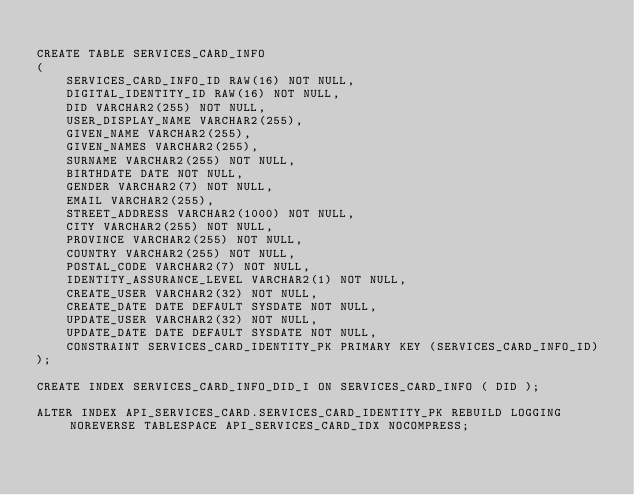Convert code to text. <code><loc_0><loc_0><loc_500><loc_500><_SQL_>
CREATE TABLE SERVICES_CARD_INFO
(
    SERVICES_CARD_INFO_ID RAW(16) NOT NULL,
    DIGITAL_IDENTITY_ID RAW(16) NOT NULL,
    DID VARCHAR2(255) NOT NULL,
    USER_DISPLAY_NAME VARCHAR2(255),
    GIVEN_NAME VARCHAR2(255),
    GIVEN_NAMES VARCHAR2(255),
    SURNAME VARCHAR2(255) NOT NULL,
    BIRTHDATE DATE NOT NULL,
    GENDER VARCHAR2(7) NOT NULL,
    EMAIL VARCHAR2(255),
    STREET_ADDRESS VARCHAR2(1000) NOT NULL,
    CITY VARCHAR2(255) NOT NULL,
    PROVINCE VARCHAR2(255) NOT NULL,
    COUNTRY VARCHAR2(255) NOT NULL,
    POSTAL_CODE VARCHAR2(7) NOT NULL,
    IDENTITY_ASSURANCE_LEVEL VARCHAR2(1) NOT NULL,
    CREATE_USER VARCHAR2(32) NOT NULL,
    CREATE_DATE DATE DEFAULT SYSDATE NOT NULL,
    UPDATE_USER VARCHAR2(32) NOT NULL,
    UPDATE_DATE DATE DEFAULT SYSDATE NOT NULL,
    CONSTRAINT SERVICES_CARD_IDENTITY_PK PRIMARY KEY (SERVICES_CARD_INFO_ID)
);

CREATE INDEX SERVICES_CARD_INFO_DID_I ON SERVICES_CARD_INFO ( DID );

ALTER INDEX API_SERVICES_CARD.SERVICES_CARD_IDENTITY_PK REBUILD LOGGING NOREVERSE TABLESPACE API_SERVICES_CARD_IDX NOCOMPRESS;
</code> 